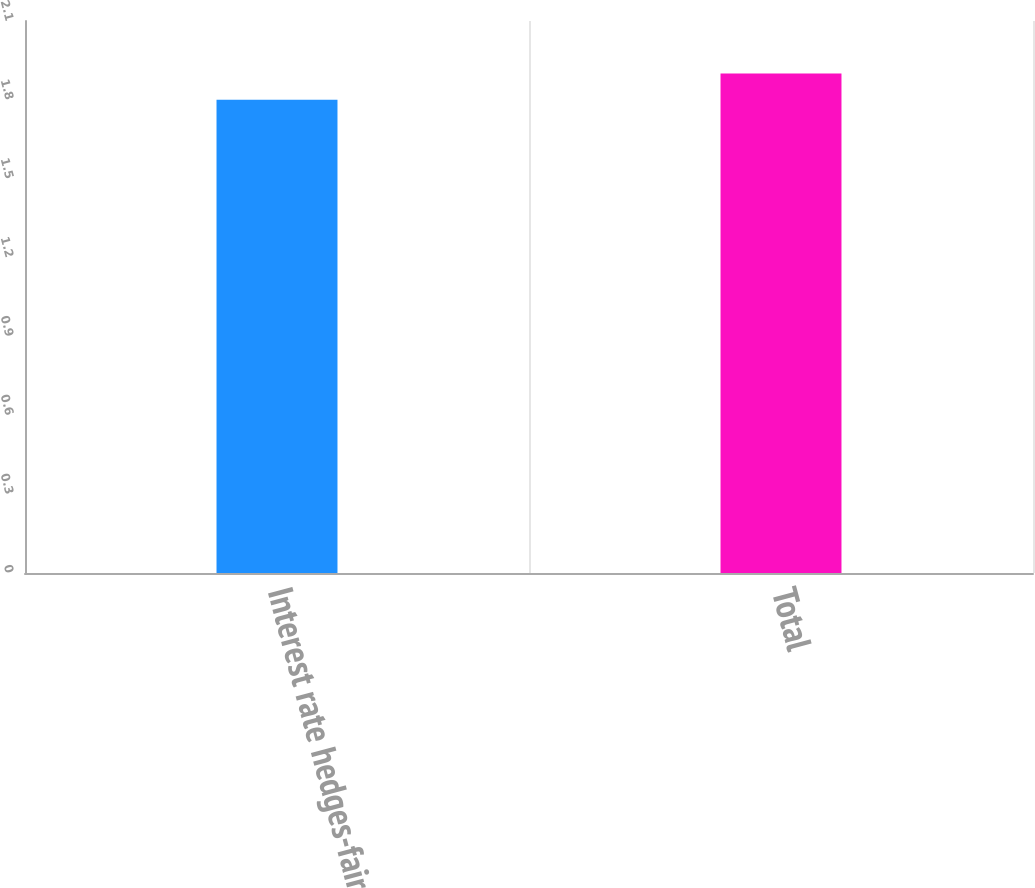Convert chart. <chart><loc_0><loc_0><loc_500><loc_500><bar_chart><fcel>Interest rate hedges-fair<fcel>Total<nl><fcel>1.8<fcel>1.9<nl></chart> 